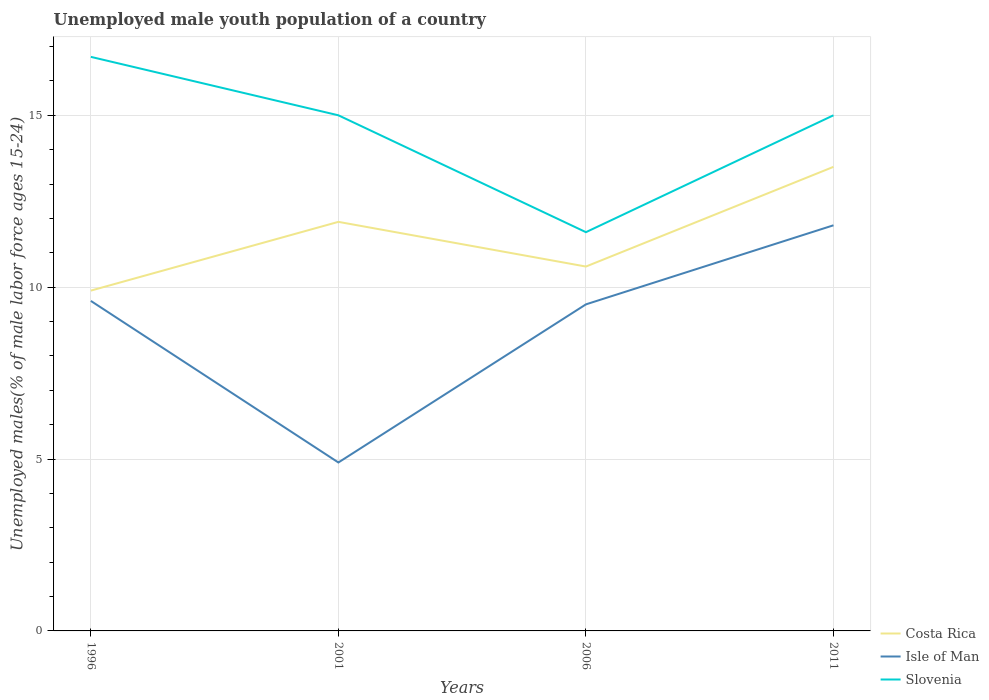Does the line corresponding to Slovenia intersect with the line corresponding to Isle of Man?
Provide a short and direct response. No. Across all years, what is the maximum percentage of unemployed male youth population in Isle of Man?
Ensure brevity in your answer.  4.9. What is the total percentage of unemployed male youth population in Isle of Man in the graph?
Offer a very short reply. -2.3. What is the difference between the highest and the second highest percentage of unemployed male youth population in Slovenia?
Your answer should be very brief. 5.1. What is the difference between two consecutive major ticks on the Y-axis?
Your response must be concise. 5. Where does the legend appear in the graph?
Give a very brief answer. Bottom right. What is the title of the graph?
Your answer should be compact. Unemployed male youth population of a country. What is the label or title of the Y-axis?
Give a very brief answer. Unemployed males(% of male labor force ages 15-24). What is the Unemployed males(% of male labor force ages 15-24) of Costa Rica in 1996?
Make the answer very short. 9.9. What is the Unemployed males(% of male labor force ages 15-24) of Isle of Man in 1996?
Give a very brief answer. 9.6. What is the Unemployed males(% of male labor force ages 15-24) of Slovenia in 1996?
Ensure brevity in your answer.  16.7. What is the Unemployed males(% of male labor force ages 15-24) in Costa Rica in 2001?
Offer a very short reply. 11.9. What is the Unemployed males(% of male labor force ages 15-24) in Isle of Man in 2001?
Your answer should be compact. 4.9. What is the Unemployed males(% of male labor force ages 15-24) of Slovenia in 2001?
Keep it short and to the point. 15. What is the Unemployed males(% of male labor force ages 15-24) of Costa Rica in 2006?
Provide a succinct answer. 10.6. What is the Unemployed males(% of male labor force ages 15-24) in Slovenia in 2006?
Your answer should be compact. 11.6. What is the Unemployed males(% of male labor force ages 15-24) in Isle of Man in 2011?
Your answer should be very brief. 11.8. What is the Unemployed males(% of male labor force ages 15-24) in Slovenia in 2011?
Your answer should be very brief. 15. Across all years, what is the maximum Unemployed males(% of male labor force ages 15-24) of Isle of Man?
Offer a very short reply. 11.8. Across all years, what is the maximum Unemployed males(% of male labor force ages 15-24) of Slovenia?
Keep it short and to the point. 16.7. Across all years, what is the minimum Unemployed males(% of male labor force ages 15-24) in Costa Rica?
Your answer should be very brief. 9.9. Across all years, what is the minimum Unemployed males(% of male labor force ages 15-24) in Isle of Man?
Provide a short and direct response. 4.9. Across all years, what is the minimum Unemployed males(% of male labor force ages 15-24) of Slovenia?
Your answer should be very brief. 11.6. What is the total Unemployed males(% of male labor force ages 15-24) of Costa Rica in the graph?
Your answer should be compact. 45.9. What is the total Unemployed males(% of male labor force ages 15-24) of Isle of Man in the graph?
Your answer should be compact. 35.8. What is the total Unemployed males(% of male labor force ages 15-24) in Slovenia in the graph?
Provide a short and direct response. 58.3. What is the difference between the Unemployed males(% of male labor force ages 15-24) in Costa Rica in 1996 and that in 2001?
Your response must be concise. -2. What is the difference between the Unemployed males(% of male labor force ages 15-24) of Isle of Man in 1996 and that in 2006?
Give a very brief answer. 0.1. What is the difference between the Unemployed males(% of male labor force ages 15-24) in Isle of Man in 1996 and that in 2011?
Give a very brief answer. -2.2. What is the difference between the Unemployed males(% of male labor force ages 15-24) in Costa Rica in 2001 and that in 2006?
Your answer should be very brief. 1.3. What is the difference between the Unemployed males(% of male labor force ages 15-24) of Slovenia in 2001 and that in 2006?
Ensure brevity in your answer.  3.4. What is the difference between the Unemployed males(% of male labor force ages 15-24) in Costa Rica in 2001 and that in 2011?
Offer a terse response. -1.6. What is the difference between the Unemployed males(% of male labor force ages 15-24) in Slovenia in 2001 and that in 2011?
Provide a short and direct response. 0. What is the difference between the Unemployed males(% of male labor force ages 15-24) in Slovenia in 2006 and that in 2011?
Provide a succinct answer. -3.4. What is the difference between the Unemployed males(% of male labor force ages 15-24) in Costa Rica in 1996 and the Unemployed males(% of male labor force ages 15-24) in Isle of Man in 2001?
Give a very brief answer. 5. What is the difference between the Unemployed males(% of male labor force ages 15-24) of Isle of Man in 1996 and the Unemployed males(% of male labor force ages 15-24) of Slovenia in 2001?
Offer a very short reply. -5.4. What is the difference between the Unemployed males(% of male labor force ages 15-24) of Costa Rica in 1996 and the Unemployed males(% of male labor force ages 15-24) of Isle of Man in 2006?
Keep it short and to the point. 0.4. What is the difference between the Unemployed males(% of male labor force ages 15-24) in Isle of Man in 1996 and the Unemployed males(% of male labor force ages 15-24) in Slovenia in 2011?
Offer a very short reply. -5.4. What is the difference between the Unemployed males(% of male labor force ages 15-24) of Costa Rica in 2001 and the Unemployed males(% of male labor force ages 15-24) of Isle of Man in 2011?
Your answer should be compact. 0.1. What is the difference between the Unemployed males(% of male labor force ages 15-24) of Costa Rica in 2006 and the Unemployed males(% of male labor force ages 15-24) of Isle of Man in 2011?
Offer a terse response. -1.2. What is the difference between the Unemployed males(% of male labor force ages 15-24) of Costa Rica in 2006 and the Unemployed males(% of male labor force ages 15-24) of Slovenia in 2011?
Give a very brief answer. -4.4. What is the difference between the Unemployed males(% of male labor force ages 15-24) of Isle of Man in 2006 and the Unemployed males(% of male labor force ages 15-24) of Slovenia in 2011?
Ensure brevity in your answer.  -5.5. What is the average Unemployed males(% of male labor force ages 15-24) in Costa Rica per year?
Offer a very short reply. 11.47. What is the average Unemployed males(% of male labor force ages 15-24) of Isle of Man per year?
Offer a terse response. 8.95. What is the average Unemployed males(% of male labor force ages 15-24) in Slovenia per year?
Offer a terse response. 14.57. In the year 1996, what is the difference between the Unemployed males(% of male labor force ages 15-24) of Costa Rica and Unemployed males(% of male labor force ages 15-24) of Slovenia?
Your answer should be very brief. -6.8. In the year 2006, what is the difference between the Unemployed males(% of male labor force ages 15-24) in Costa Rica and Unemployed males(% of male labor force ages 15-24) in Isle of Man?
Ensure brevity in your answer.  1.1. In the year 2006, what is the difference between the Unemployed males(% of male labor force ages 15-24) of Costa Rica and Unemployed males(% of male labor force ages 15-24) of Slovenia?
Your response must be concise. -1. What is the ratio of the Unemployed males(% of male labor force ages 15-24) in Costa Rica in 1996 to that in 2001?
Provide a short and direct response. 0.83. What is the ratio of the Unemployed males(% of male labor force ages 15-24) in Isle of Man in 1996 to that in 2001?
Your answer should be compact. 1.96. What is the ratio of the Unemployed males(% of male labor force ages 15-24) of Slovenia in 1996 to that in 2001?
Your response must be concise. 1.11. What is the ratio of the Unemployed males(% of male labor force ages 15-24) in Costa Rica in 1996 to that in 2006?
Make the answer very short. 0.93. What is the ratio of the Unemployed males(% of male labor force ages 15-24) of Isle of Man in 1996 to that in 2006?
Keep it short and to the point. 1.01. What is the ratio of the Unemployed males(% of male labor force ages 15-24) in Slovenia in 1996 to that in 2006?
Give a very brief answer. 1.44. What is the ratio of the Unemployed males(% of male labor force ages 15-24) of Costa Rica in 1996 to that in 2011?
Provide a succinct answer. 0.73. What is the ratio of the Unemployed males(% of male labor force ages 15-24) of Isle of Man in 1996 to that in 2011?
Keep it short and to the point. 0.81. What is the ratio of the Unemployed males(% of male labor force ages 15-24) of Slovenia in 1996 to that in 2011?
Provide a succinct answer. 1.11. What is the ratio of the Unemployed males(% of male labor force ages 15-24) in Costa Rica in 2001 to that in 2006?
Your answer should be very brief. 1.12. What is the ratio of the Unemployed males(% of male labor force ages 15-24) of Isle of Man in 2001 to that in 2006?
Your response must be concise. 0.52. What is the ratio of the Unemployed males(% of male labor force ages 15-24) of Slovenia in 2001 to that in 2006?
Offer a very short reply. 1.29. What is the ratio of the Unemployed males(% of male labor force ages 15-24) of Costa Rica in 2001 to that in 2011?
Give a very brief answer. 0.88. What is the ratio of the Unemployed males(% of male labor force ages 15-24) in Isle of Man in 2001 to that in 2011?
Offer a terse response. 0.42. What is the ratio of the Unemployed males(% of male labor force ages 15-24) of Slovenia in 2001 to that in 2011?
Offer a terse response. 1. What is the ratio of the Unemployed males(% of male labor force ages 15-24) in Costa Rica in 2006 to that in 2011?
Offer a very short reply. 0.79. What is the ratio of the Unemployed males(% of male labor force ages 15-24) of Isle of Man in 2006 to that in 2011?
Provide a succinct answer. 0.81. What is the ratio of the Unemployed males(% of male labor force ages 15-24) of Slovenia in 2006 to that in 2011?
Your response must be concise. 0.77. What is the difference between the highest and the second highest Unemployed males(% of male labor force ages 15-24) of Costa Rica?
Provide a short and direct response. 1.6. What is the difference between the highest and the second highest Unemployed males(% of male labor force ages 15-24) in Isle of Man?
Keep it short and to the point. 2.2. What is the difference between the highest and the second highest Unemployed males(% of male labor force ages 15-24) in Slovenia?
Make the answer very short. 1.7. What is the difference between the highest and the lowest Unemployed males(% of male labor force ages 15-24) of Isle of Man?
Offer a very short reply. 6.9. What is the difference between the highest and the lowest Unemployed males(% of male labor force ages 15-24) of Slovenia?
Your response must be concise. 5.1. 